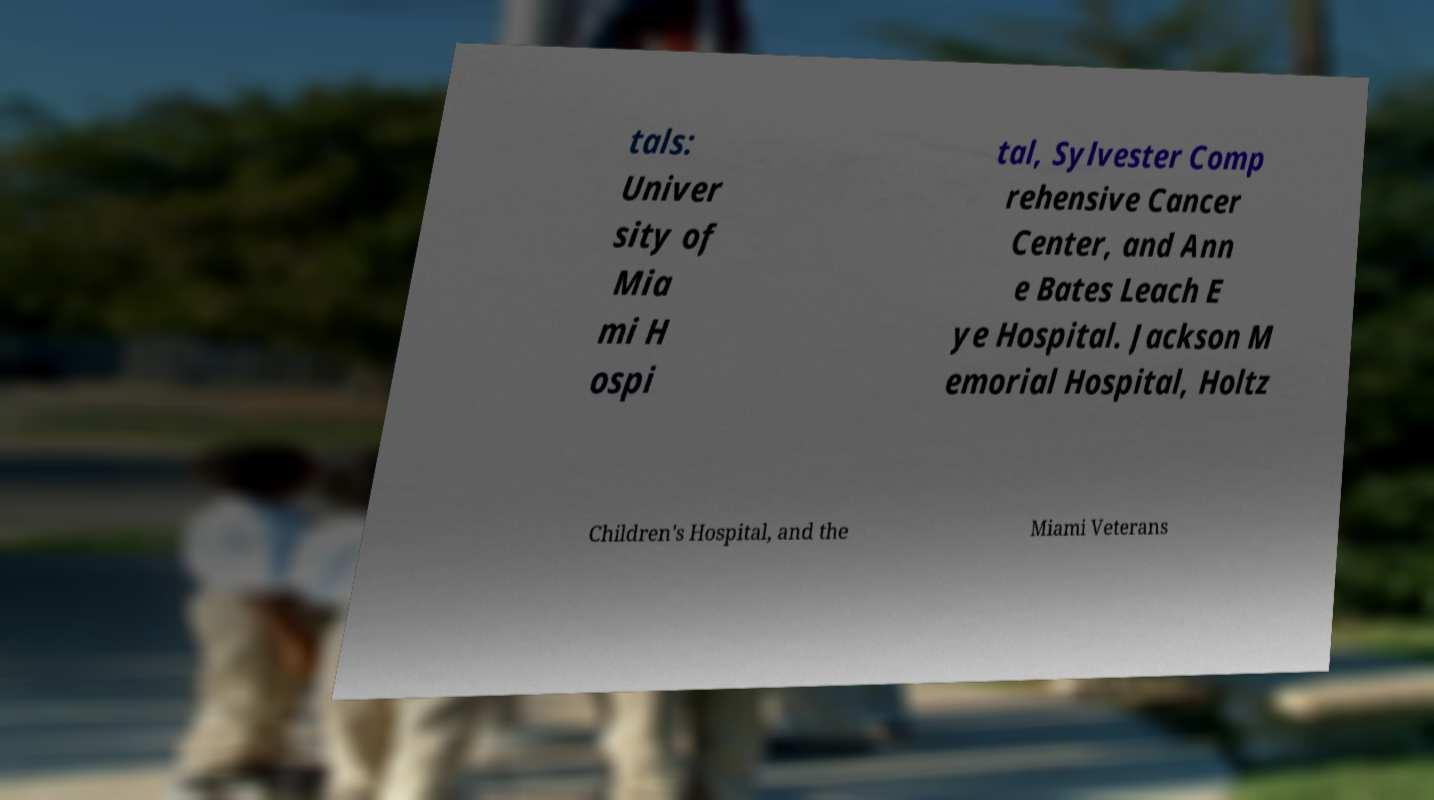What messages or text are displayed in this image? I need them in a readable, typed format. tals: Univer sity of Mia mi H ospi tal, Sylvester Comp rehensive Cancer Center, and Ann e Bates Leach E ye Hospital. Jackson M emorial Hospital, Holtz Children's Hospital, and the Miami Veterans 